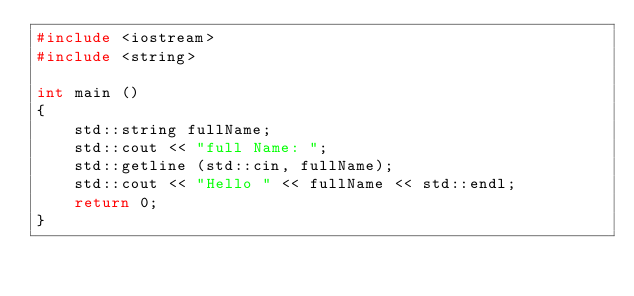<code> <loc_0><loc_0><loc_500><loc_500><_C++_>#include <iostream>
#include <string>

int main ()
{
	std::string fullName;
	std::cout << "full Name: ";
	std::getline (std::cin, fullName);
	std::cout << "Hello " << fullName << std::endl;
	return 0;
}
</code> 